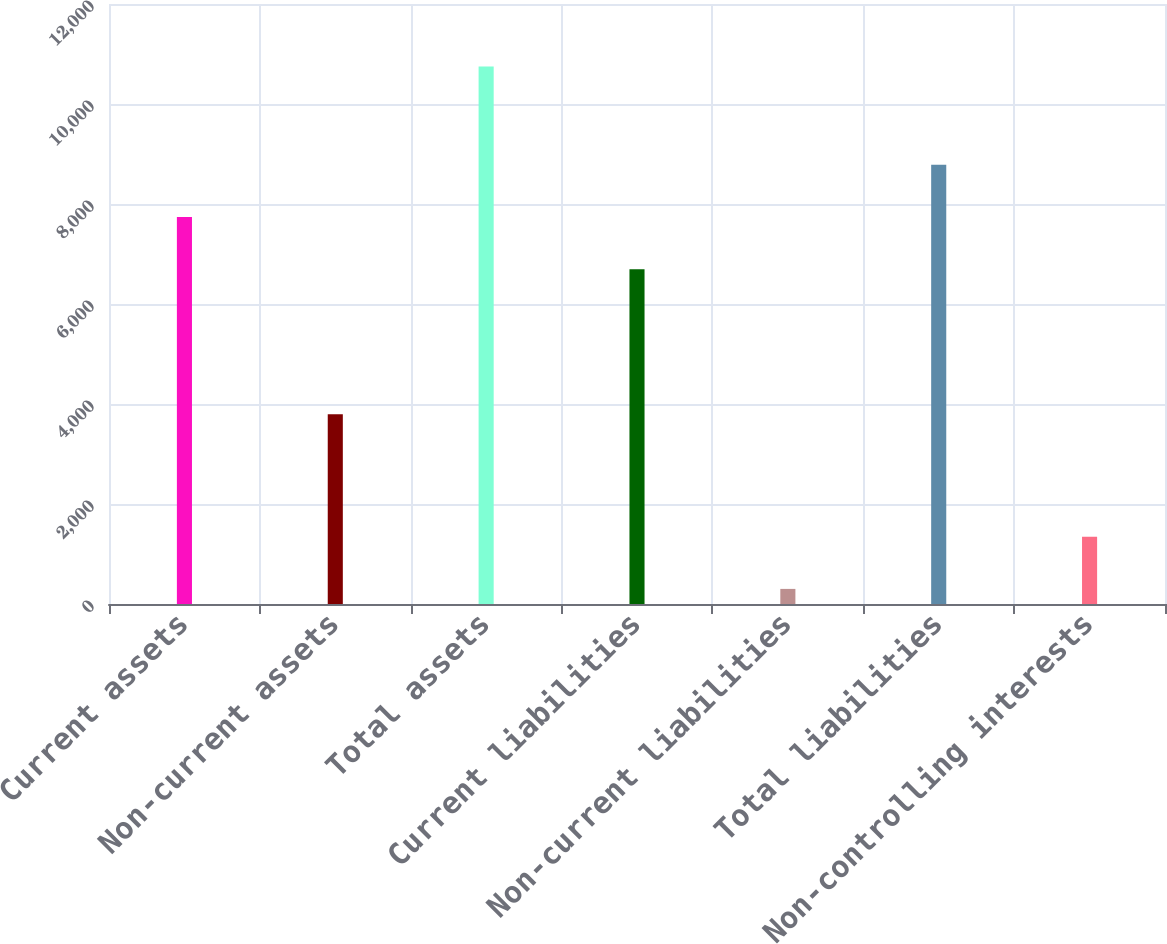<chart> <loc_0><loc_0><loc_500><loc_500><bar_chart><fcel>Current assets<fcel>Non-current assets<fcel>Total assets<fcel>Current liabilities<fcel>Non-current liabilities<fcel>Total liabilities<fcel>Non-controlling interests<nl><fcel>7739.6<fcel>3794<fcel>10748<fcel>6695<fcel>302<fcel>8784.2<fcel>1346.6<nl></chart> 